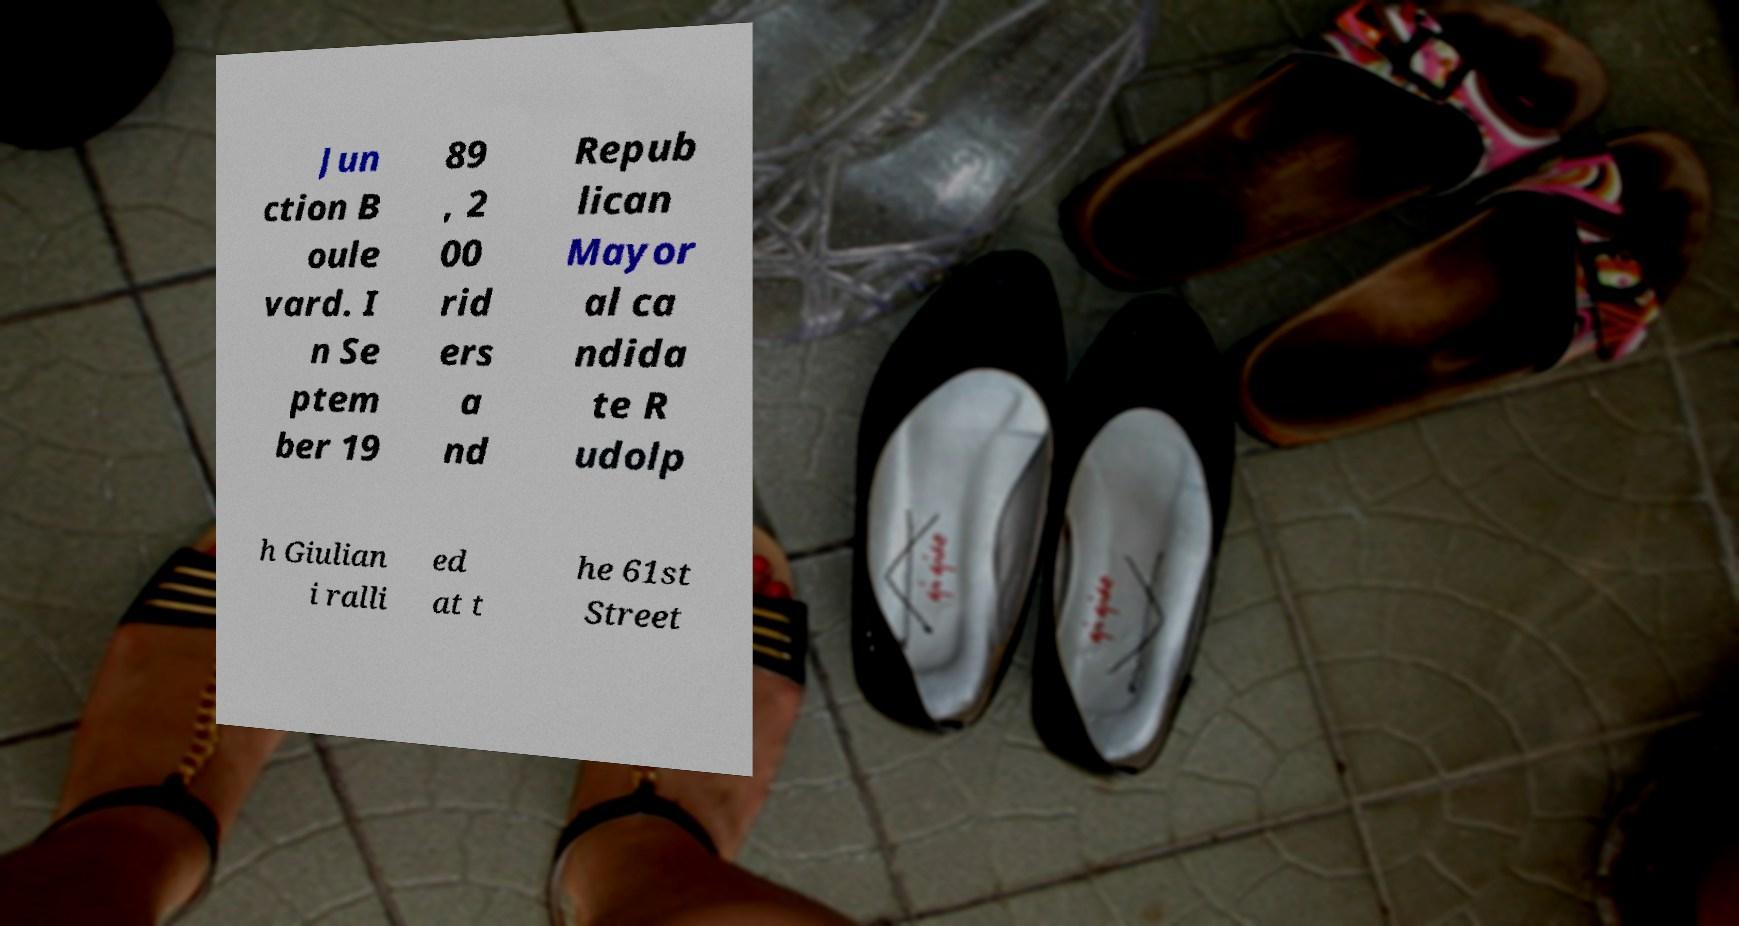Could you assist in decoding the text presented in this image and type it out clearly? Jun ction B oule vard. I n Se ptem ber 19 89 , 2 00 rid ers a nd Repub lican Mayor al ca ndida te R udolp h Giulian i ralli ed at t he 61st Street 